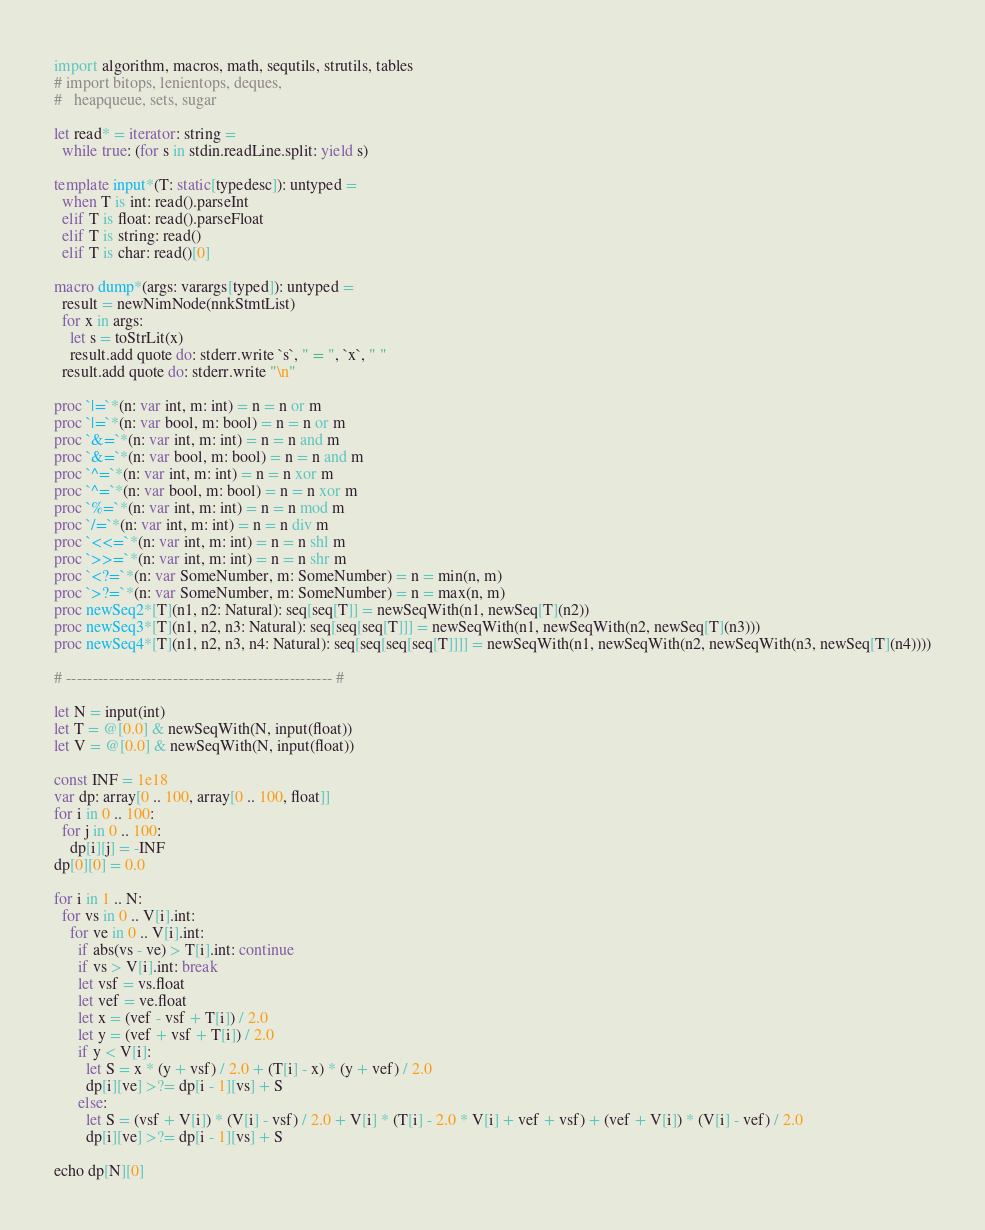Convert code to text. <code><loc_0><loc_0><loc_500><loc_500><_Nim_>import algorithm, macros, math, sequtils, strutils, tables
# import bitops, lenientops, deques,
#   heapqueue, sets, sugar

let read* = iterator: string =
  while true: (for s in stdin.readLine.split: yield s)

template input*(T: static[typedesc]): untyped = 
  when T is int: read().parseInt
  elif T is float: read().parseFloat
  elif T is string: read()
  elif T is char: read()[0]

macro dump*(args: varargs[typed]): untyped =
  result = newNimNode(nnkStmtList)
  for x in args:
    let s = toStrLit(x)
    result.add quote do: stderr.write `s`, " = ", `x`, " "
  result.add quote do: stderr.write "\n"

proc `|=`*(n: var int, m: int) = n = n or m
proc `|=`*(n: var bool, m: bool) = n = n or m
proc `&=`*(n: var int, m: int) = n = n and m
proc `&=`*(n: var bool, m: bool) = n = n and m
proc `^=`*(n: var int, m: int) = n = n xor m
proc `^=`*(n: var bool, m: bool) = n = n xor m
proc `%=`*(n: var int, m: int) = n = n mod m
proc `/=`*(n: var int, m: int) = n = n div m
proc `<<=`*(n: var int, m: int) = n = n shl m
proc `>>=`*(n: var int, m: int) = n = n shr m
proc `<?=`*(n: var SomeNumber, m: SomeNumber) = n = min(n, m)
proc `>?=`*(n: var SomeNumber, m: SomeNumber) = n = max(n, m)
proc newSeq2*[T](n1, n2: Natural): seq[seq[T]] = newSeqWith(n1, newSeq[T](n2))
proc newSeq3*[T](n1, n2, n3: Natural): seq[seq[seq[T]]] = newSeqWith(n1, newSeqWith(n2, newSeq[T](n3)))
proc newSeq4*[T](n1, n2, n3, n4: Natural): seq[seq[seq[seq[T]]]] = newSeqWith(n1, newSeqWith(n2, newSeqWith(n3, newSeq[T](n4))))

# -------------------------------------------------- #

let N = input(int)
let T = @[0.0] & newSeqWith(N, input(float))
let V = @[0.0] & newSeqWith(N, input(float))

const INF = 1e18
var dp: array[0 .. 100, array[0 .. 100, float]]
for i in 0 .. 100:
  for j in 0 .. 100:
    dp[i][j] = -INF
dp[0][0] = 0.0

for i in 1 .. N:
  for vs in 0 .. V[i].int:
    for ve in 0 .. V[i].int:
      if abs(vs - ve) > T[i].int: continue
      if vs > V[i].int: break
      let vsf = vs.float
      let vef = ve.float
      let x = (vef - vsf + T[i]) / 2.0
      let y = (vef + vsf + T[i]) / 2.0
      if y < V[i]:
        let S = x * (y + vsf) / 2.0 + (T[i] - x) * (y + vef) / 2.0
        dp[i][ve] >?= dp[i - 1][vs] + S
      else:
        let S = (vsf + V[i]) * (V[i] - vsf) / 2.0 + V[i] * (T[i] - 2.0 * V[i] + vef + vsf) + (vef + V[i]) * (V[i] - vef) / 2.0
        dp[i][ve] >?= dp[i - 1][vs] + S

echo dp[N][0]
</code> 